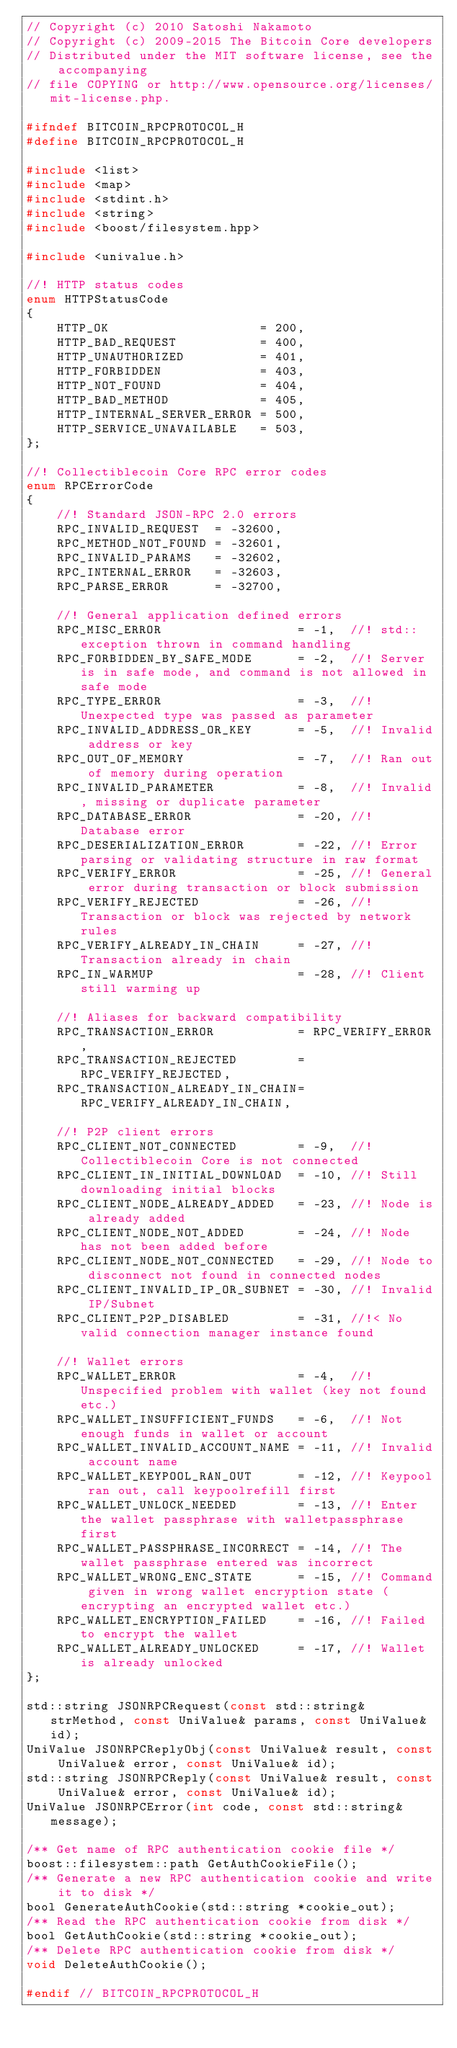Convert code to text. <code><loc_0><loc_0><loc_500><loc_500><_C_>// Copyright (c) 2010 Satoshi Nakamoto
// Copyright (c) 2009-2015 The Bitcoin Core developers
// Distributed under the MIT software license, see the accompanying
// file COPYING or http://www.opensource.org/licenses/mit-license.php.

#ifndef BITCOIN_RPCPROTOCOL_H
#define BITCOIN_RPCPROTOCOL_H

#include <list>
#include <map>
#include <stdint.h>
#include <string>
#include <boost/filesystem.hpp>

#include <univalue.h>

//! HTTP status codes
enum HTTPStatusCode
{
    HTTP_OK                    = 200,
    HTTP_BAD_REQUEST           = 400,
    HTTP_UNAUTHORIZED          = 401,
    HTTP_FORBIDDEN             = 403,
    HTTP_NOT_FOUND             = 404,
    HTTP_BAD_METHOD            = 405,
    HTTP_INTERNAL_SERVER_ERROR = 500,
    HTTP_SERVICE_UNAVAILABLE   = 503,
};

//! Collectiblecoin Core RPC error codes
enum RPCErrorCode
{
    //! Standard JSON-RPC 2.0 errors
    RPC_INVALID_REQUEST  = -32600,
    RPC_METHOD_NOT_FOUND = -32601,
    RPC_INVALID_PARAMS   = -32602,
    RPC_INTERNAL_ERROR   = -32603,
    RPC_PARSE_ERROR      = -32700,

    //! General application defined errors
    RPC_MISC_ERROR                  = -1,  //! std::exception thrown in command handling
    RPC_FORBIDDEN_BY_SAFE_MODE      = -2,  //! Server is in safe mode, and command is not allowed in safe mode
    RPC_TYPE_ERROR                  = -3,  //! Unexpected type was passed as parameter
    RPC_INVALID_ADDRESS_OR_KEY      = -5,  //! Invalid address or key
    RPC_OUT_OF_MEMORY               = -7,  //! Ran out of memory during operation
    RPC_INVALID_PARAMETER           = -8,  //! Invalid, missing or duplicate parameter
    RPC_DATABASE_ERROR              = -20, //! Database error
    RPC_DESERIALIZATION_ERROR       = -22, //! Error parsing or validating structure in raw format
    RPC_VERIFY_ERROR                = -25, //! General error during transaction or block submission
    RPC_VERIFY_REJECTED             = -26, //! Transaction or block was rejected by network rules
    RPC_VERIFY_ALREADY_IN_CHAIN     = -27, //! Transaction already in chain
    RPC_IN_WARMUP                   = -28, //! Client still warming up

    //! Aliases for backward compatibility
    RPC_TRANSACTION_ERROR           = RPC_VERIFY_ERROR,
    RPC_TRANSACTION_REJECTED        = RPC_VERIFY_REJECTED,
    RPC_TRANSACTION_ALREADY_IN_CHAIN= RPC_VERIFY_ALREADY_IN_CHAIN,

    //! P2P client errors
    RPC_CLIENT_NOT_CONNECTED        = -9,  //! Collectiblecoin Core is not connected
    RPC_CLIENT_IN_INITIAL_DOWNLOAD  = -10, //! Still downloading initial blocks
    RPC_CLIENT_NODE_ALREADY_ADDED   = -23, //! Node is already added
    RPC_CLIENT_NODE_NOT_ADDED       = -24, //! Node has not been added before
    RPC_CLIENT_NODE_NOT_CONNECTED   = -29, //! Node to disconnect not found in connected nodes
    RPC_CLIENT_INVALID_IP_OR_SUBNET = -30, //! Invalid IP/Subnet
    RPC_CLIENT_P2P_DISABLED         = -31, //!< No valid connection manager instance found

    //! Wallet errors
    RPC_WALLET_ERROR                = -4,  //! Unspecified problem with wallet (key not found etc.)
    RPC_WALLET_INSUFFICIENT_FUNDS   = -6,  //! Not enough funds in wallet or account
    RPC_WALLET_INVALID_ACCOUNT_NAME = -11, //! Invalid account name
    RPC_WALLET_KEYPOOL_RAN_OUT      = -12, //! Keypool ran out, call keypoolrefill first
    RPC_WALLET_UNLOCK_NEEDED        = -13, //! Enter the wallet passphrase with walletpassphrase first
    RPC_WALLET_PASSPHRASE_INCORRECT = -14, //! The wallet passphrase entered was incorrect
    RPC_WALLET_WRONG_ENC_STATE      = -15, //! Command given in wrong wallet encryption state (encrypting an encrypted wallet etc.)
    RPC_WALLET_ENCRYPTION_FAILED    = -16, //! Failed to encrypt the wallet
    RPC_WALLET_ALREADY_UNLOCKED     = -17, //! Wallet is already unlocked
};

std::string JSONRPCRequest(const std::string& strMethod, const UniValue& params, const UniValue& id);
UniValue JSONRPCReplyObj(const UniValue& result, const UniValue& error, const UniValue& id);
std::string JSONRPCReply(const UniValue& result, const UniValue& error, const UniValue& id);
UniValue JSONRPCError(int code, const std::string& message);

/** Get name of RPC authentication cookie file */
boost::filesystem::path GetAuthCookieFile();
/** Generate a new RPC authentication cookie and write it to disk */
bool GenerateAuthCookie(std::string *cookie_out);
/** Read the RPC authentication cookie from disk */
bool GetAuthCookie(std::string *cookie_out);
/** Delete RPC authentication cookie from disk */
void DeleteAuthCookie();

#endif // BITCOIN_RPCPROTOCOL_H
</code> 